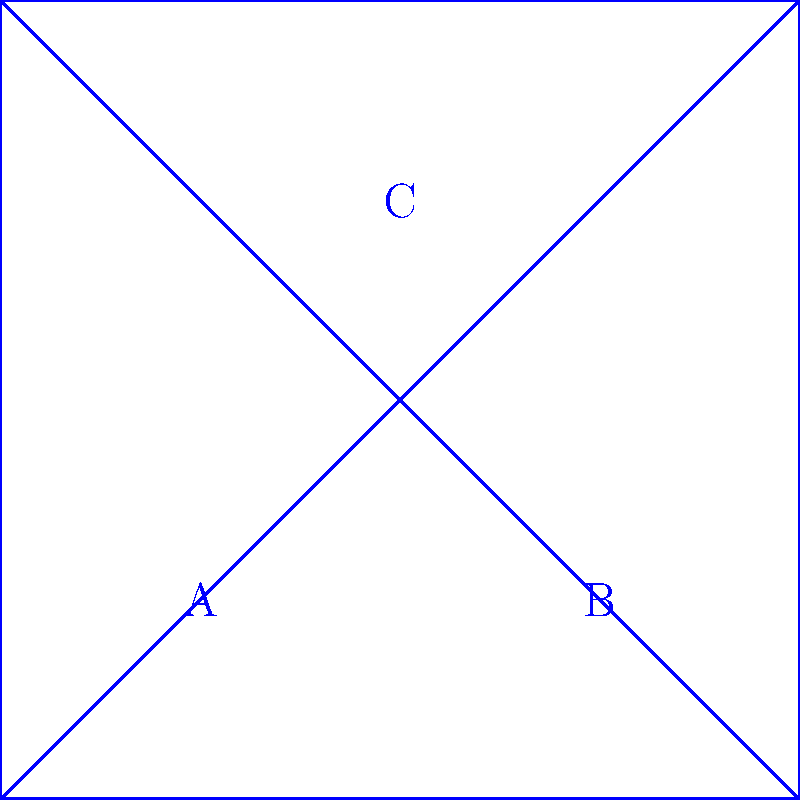The flattened map shows community resources A, B, and C. If this map is folded into a cube to match the 3D model, which resource on the flattened map corresponds to point Y on the 3D model? To solve this problem, we need to mentally fold the flattened map into a cube and match it with the 3D model. Let's follow these steps:

1. Observe that the flattened map is a net of a cube, with four squares forming the sides and two triangles forming the top and bottom.

2. Notice that resources A, B, and C are positioned on different faces of the unfolded cube.

3. When folded, the map will form a cube where:
   - A and B will be on opposite faces
   - C will be on the top face

4. Looking at the 3D model, we can see that:
   - X is on the front face
   - Y is on the right face
   - Z is on the top face

5. Since C corresponds to Z (both on top), we need to determine whether A or B corresponds to Y.

6. When folding the map, B will be on the right face of the cube, matching the position of Y on the 3D model.

Therefore, resource B on the flattened map corresponds to point Y on the 3D model.
Answer: B 